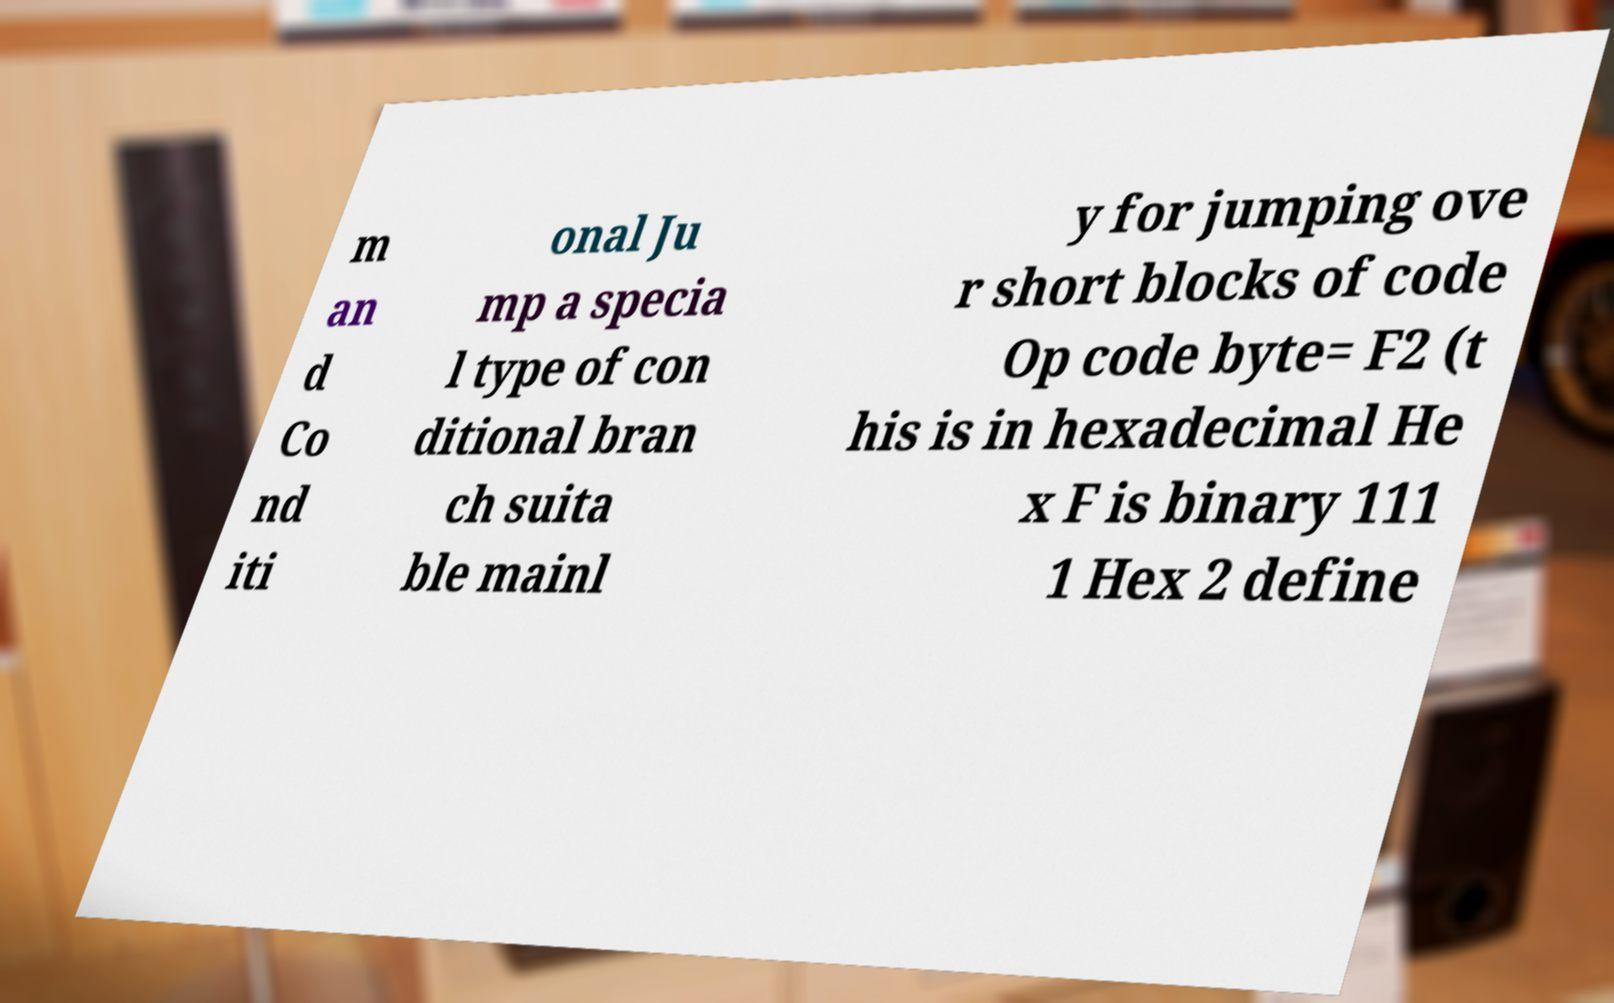Please read and relay the text visible in this image. What does it say? m an d Co nd iti onal Ju mp a specia l type of con ditional bran ch suita ble mainl y for jumping ove r short blocks of code Op code byte= F2 (t his is in hexadecimal He x F is binary 111 1 Hex 2 define 